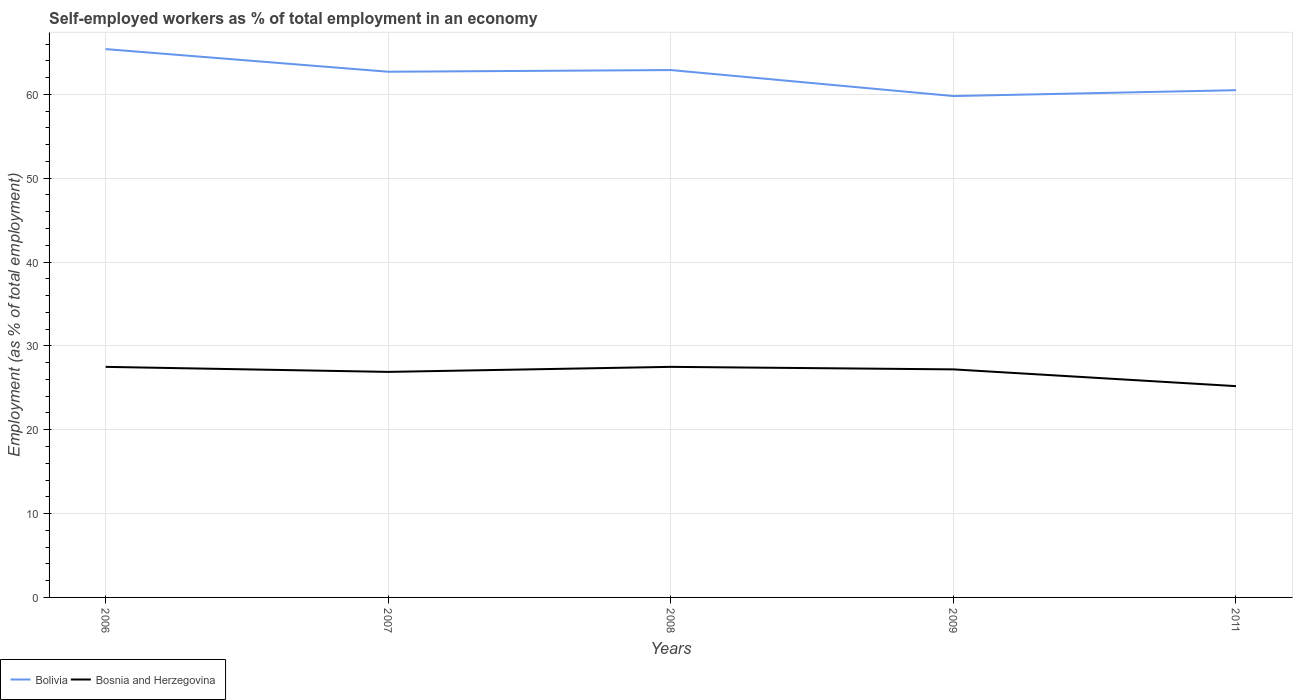Across all years, what is the maximum percentage of self-employed workers in Bolivia?
Your response must be concise. 59.8. In which year was the percentage of self-employed workers in Bolivia maximum?
Keep it short and to the point. 2009. What is the total percentage of self-employed workers in Bolivia in the graph?
Your answer should be very brief. 3.1. What is the difference between the highest and the second highest percentage of self-employed workers in Bosnia and Herzegovina?
Offer a terse response. 2.3. What is the difference between the highest and the lowest percentage of self-employed workers in Bolivia?
Make the answer very short. 3. Is the percentage of self-employed workers in Bolivia strictly greater than the percentage of self-employed workers in Bosnia and Herzegovina over the years?
Your response must be concise. No. How many years are there in the graph?
Keep it short and to the point. 5. Are the values on the major ticks of Y-axis written in scientific E-notation?
Provide a succinct answer. No. Does the graph contain any zero values?
Give a very brief answer. No. How many legend labels are there?
Provide a succinct answer. 2. What is the title of the graph?
Offer a very short reply. Self-employed workers as % of total employment in an economy. Does "Niger" appear as one of the legend labels in the graph?
Give a very brief answer. No. What is the label or title of the Y-axis?
Provide a succinct answer. Employment (as % of total employment). What is the Employment (as % of total employment) in Bolivia in 2006?
Make the answer very short. 65.4. What is the Employment (as % of total employment) in Bosnia and Herzegovina in 2006?
Provide a short and direct response. 27.5. What is the Employment (as % of total employment) of Bolivia in 2007?
Make the answer very short. 62.7. What is the Employment (as % of total employment) of Bosnia and Herzegovina in 2007?
Make the answer very short. 26.9. What is the Employment (as % of total employment) in Bolivia in 2008?
Your answer should be very brief. 62.9. What is the Employment (as % of total employment) in Bolivia in 2009?
Make the answer very short. 59.8. What is the Employment (as % of total employment) in Bosnia and Herzegovina in 2009?
Your response must be concise. 27.2. What is the Employment (as % of total employment) of Bolivia in 2011?
Your answer should be very brief. 60.5. What is the Employment (as % of total employment) of Bosnia and Herzegovina in 2011?
Your response must be concise. 25.2. Across all years, what is the maximum Employment (as % of total employment) in Bolivia?
Provide a short and direct response. 65.4. Across all years, what is the maximum Employment (as % of total employment) of Bosnia and Herzegovina?
Your response must be concise. 27.5. Across all years, what is the minimum Employment (as % of total employment) in Bolivia?
Give a very brief answer. 59.8. Across all years, what is the minimum Employment (as % of total employment) in Bosnia and Herzegovina?
Your response must be concise. 25.2. What is the total Employment (as % of total employment) in Bolivia in the graph?
Your response must be concise. 311.3. What is the total Employment (as % of total employment) in Bosnia and Herzegovina in the graph?
Make the answer very short. 134.3. What is the difference between the Employment (as % of total employment) of Bosnia and Herzegovina in 2006 and that in 2007?
Provide a short and direct response. 0.6. What is the difference between the Employment (as % of total employment) of Bolivia in 2006 and that in 2008?
Give a very brief answer. 2.5. What is the difference between the Employment (as % of total employment) in Bosnia and Herzegovina in 2006 and that in 2008?
Offer a terse response. 0. What is the difference between the Employment (as % of total employment) of Bolivia in 2006 and that in 2011?
Offer a terse response. 4.9. What is the difference between the Employment (as % of total employment) in Bolivia in 2007 and that in 2008?
Your answer should be compact. -0.2. What is the difference between the Employment (as % of total employment) in Bosnia and Herzegovina in 2007 and that in 2008?
Provide a succinct answer. -0.6. What is the difference between the Employment (as % of total employment) in Bolivia in 2007 and that in 2009?
Provide a short and direct response. 2.9. What is the difference between the Employment (as % of total employment) of Bosnia and Herzegovina in 2007 and that in 2011?
Offer a terse response. 1.7. What is the difference between the Employment (as % of total employment) of Bosnia and Herzegovina in 2008 and that in 2009?
Make the answer very short. 0.3. What is the difference between the Employment (as % of total employment) in Bolivia in 2008 and that in 2011?
Provide a short and direct response. 2.4. What is the difference between the Employment (as % of total employment) in Bosnia and Herzegovina in 2008 and that in 2011?
Your answer should be very brief. 2.3. What is the difference between the Employment (as % of total employment) in Bolivia in 2006 and the Employment (as % of total employment) in Bosnia and Herzegovina in 2007?
Give a very brief answer. 38.5. What is the difference between the Employment (as % of total employment) of Bolivia in 2006 and the Employment (as % of total employment) of Bosnia and Herzegovina in 2008?
Offer a very short reply. 37.9. What is the difference between the Employment (as % of total employment) of Bolivia in 2006 and the Employment (as % of total employment) of Bosnia and Herzegovina in 2009?
Make the answer very short. 38.2. What is the difference between the Employment (as % of total employment) in Bolivia in 2006 and the Employment (as % of total employment) in Bosnia and Herzegovina in 2011?
Provide a succinct answer. 40.2. What is the difference between the Employment (as % of total employment) in Bolivia in 2007 and the Employment (as % of total employment) in Bosnia and Herzegovina in 2008?
Your answer should be compact. 35.2. What is the difference between the Employment (as % of total employment) in Bolivia in 2007 and the Employment (as % of total employment) in Bosnia and Herzegovina in 2009?
Your answer should be compact. 35.5. What is the difference between the Employment (as % of total employment) of Bolivia in 2007 and the Employment (as % of total employment) of Bosnia and Herzegovina in 2011?
Offer a terse response. 37.5. What is the difference between the Employment (as % of total employment) in Bolivia in 2008 and the Employment (as % of total employment) in Bosnia and Herzegovina in 2009?
Make the answer very short. 35.7. What is the difference between the Employment (as % of total employment) of Bolivia in 2008 and the Employment (as % of total employment) of Bosnia and Herzegovina in 2011?
Your answer should be very brief. 37.7. What is the difference between the Employment (as % of total employment) in Bolivia in 2009 and the Employment (as % of total employment) in Bosnia and Herzegovina in 2011?
Offer a very short reply. 34.6. What is the average Employment (as % of total employment) in Bolivia per year?
Provide a succinct answer. 62.26. What is the average Employment (as % of total employment) in Bosnia and Herzegovina per year?
Offer a very short reply. 26.86. In the year 2006, what is the difference between the Employment (as % of total employment) of Bolivia and Employment (as % of total employment) of Bosnia and Herzegovina?
Your answer should be compact. 37.9. In the year 2007, what is the difference between the Employment (as % of total employment) of Bolivia and Employment (as % of total employment) of Bosnia and Herzegovina?
Your answer should be compact. 35.8. In the year 2008, what is the difference between the Employment (as % of total employment) of Bolivia and Employment (as % of total employment) of Bosnia and Herzegovina?
Provide a succinct answer. 35.4. In the year 2009, what is the difference between the Employment (as % of total employment) of Bolivia and Employment (as % of total employment) of Bosnia and Herzegovina?
Your answer should be very brief. 32.6. In the year 2011, what is the difference between the Employment (as % of total employment) of Bolivia and Employment (as % of total employment) of Bosnia and Herzegovina?
Your answer should be compact. 35.3. What is the ratio of the Employment (as % of total employment) of Bolivia in 2006 to that in 2007?
Provide a succinct answer. 1.04. What is the ratio of the Employment (as % of total employment) of Bosnia and Herzegovina in 2006 to that in 2007?
Keep it short and to the point. 1.02. What is the ratio of the Employment (as % of total employment) in Bolivia in 2006 to that in 2008?
Offer a terse response. 1.04. What is the ratio of the Employment (as % of total employment) of Bolivia in 2006 to that in 2009?
Give a very brief answer. 1.09. What is the ratio of the Employment (as % of total employment) of Bolivia in 2006 to that in 2011?
Provide a succinct answer. 1.08. What is the ratio of the Employment (as % of total employment) of Bosnia and Herzegovina in 2006 to that in 2011?
Ensure brevity in your answer.  1.09. What is the ratio of the Employment (as % of total employment) of Bolivia in 2007 to that in 2008?
Offer a very short reply. 1. What is the ratio of the Employment (as % of total employment) of Bosnia and Herzegovina in 2007 to that in 2008?
Keep it short and to the point. 0.98. What is the ratio of the Employment (as % of total employment) in Bolivia in 2007 to that in 2009?
Ensure brevity in your answer.  1.05. What is the ratio of the Employment (as % of total employment) in Bosnia and Herzegovina in 2007 to that in 2009?
Offer a terse response. 0.99. What is the ratio of the Employment (as % of total employment) of Bolivia in 2007 to that in 2011?
Make the answer very short. 1.04. What is the ratio of the Employment (as % of total employment) of Bosnia and Herzegovina in 2007 to that in 2011?
Make the answer very short. 1.07. What is the ratio of the Employment (as % of total employment) of Bolivia in 2008 to that in 2009?
Your response must be concise. 1.05. What is the ratio of the Employment (as % of total employment) of Bosnia and Herzegovina in 2008 to that in 2009?
Keep it short and to the point. 1.01. What is the ratio of the Employment (as % of total employment) of Bolivia in 2008 to that in 2011?
Provide a succinct answer. 1.04. What is the ratio of the Employment (as % of total employment) of Bosnia and Herzegovina in 2008 to that in 2011?
Make the answer very short. 1.09. What is the ratio of the Employment (as % of total employment) in Bolivia in 2009 to that in 2011?
Offer a terse response. 0.99. What is the ratio of the Employment (as % of total employment) of Bosnia and Herzegovina in 2009 to that in 2011?
Provide a succinct answer. 1.08. What is the difference between the highest and the lowest Employment (as % of total employment) of Bolivia?
Offer a very short reply. 5.6. 